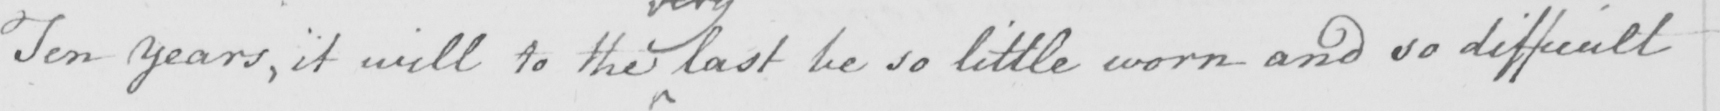Please provide the text content of this handwritten line. Ten years , it will to the last be so little worn and so difficult 